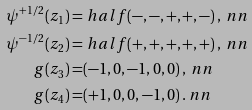Convert formula to latex. <formula><loc_0><loc_0><loc_500><loc_500>\psi ^ { + 1 / 2 } ( z _ { 1 } ) = & \ h a l f ( - , - , + , + , - ) \, , \ n n \\ \psi ^ { - 1 / 2 } ( z _ { 2 } ) = & \ h a l f ( + , + , + , + , + ) \, , \ n n \\ g ( z _ { 3 } ) = & ( - 1 , 0 , - 1 , 0 , 0 ) \, , \ n n \\ g ( z _ { 4 } ) = & ( + 1 , 0 , 0 , - 1 , 0 ) \, . \ n n \\</formula> 